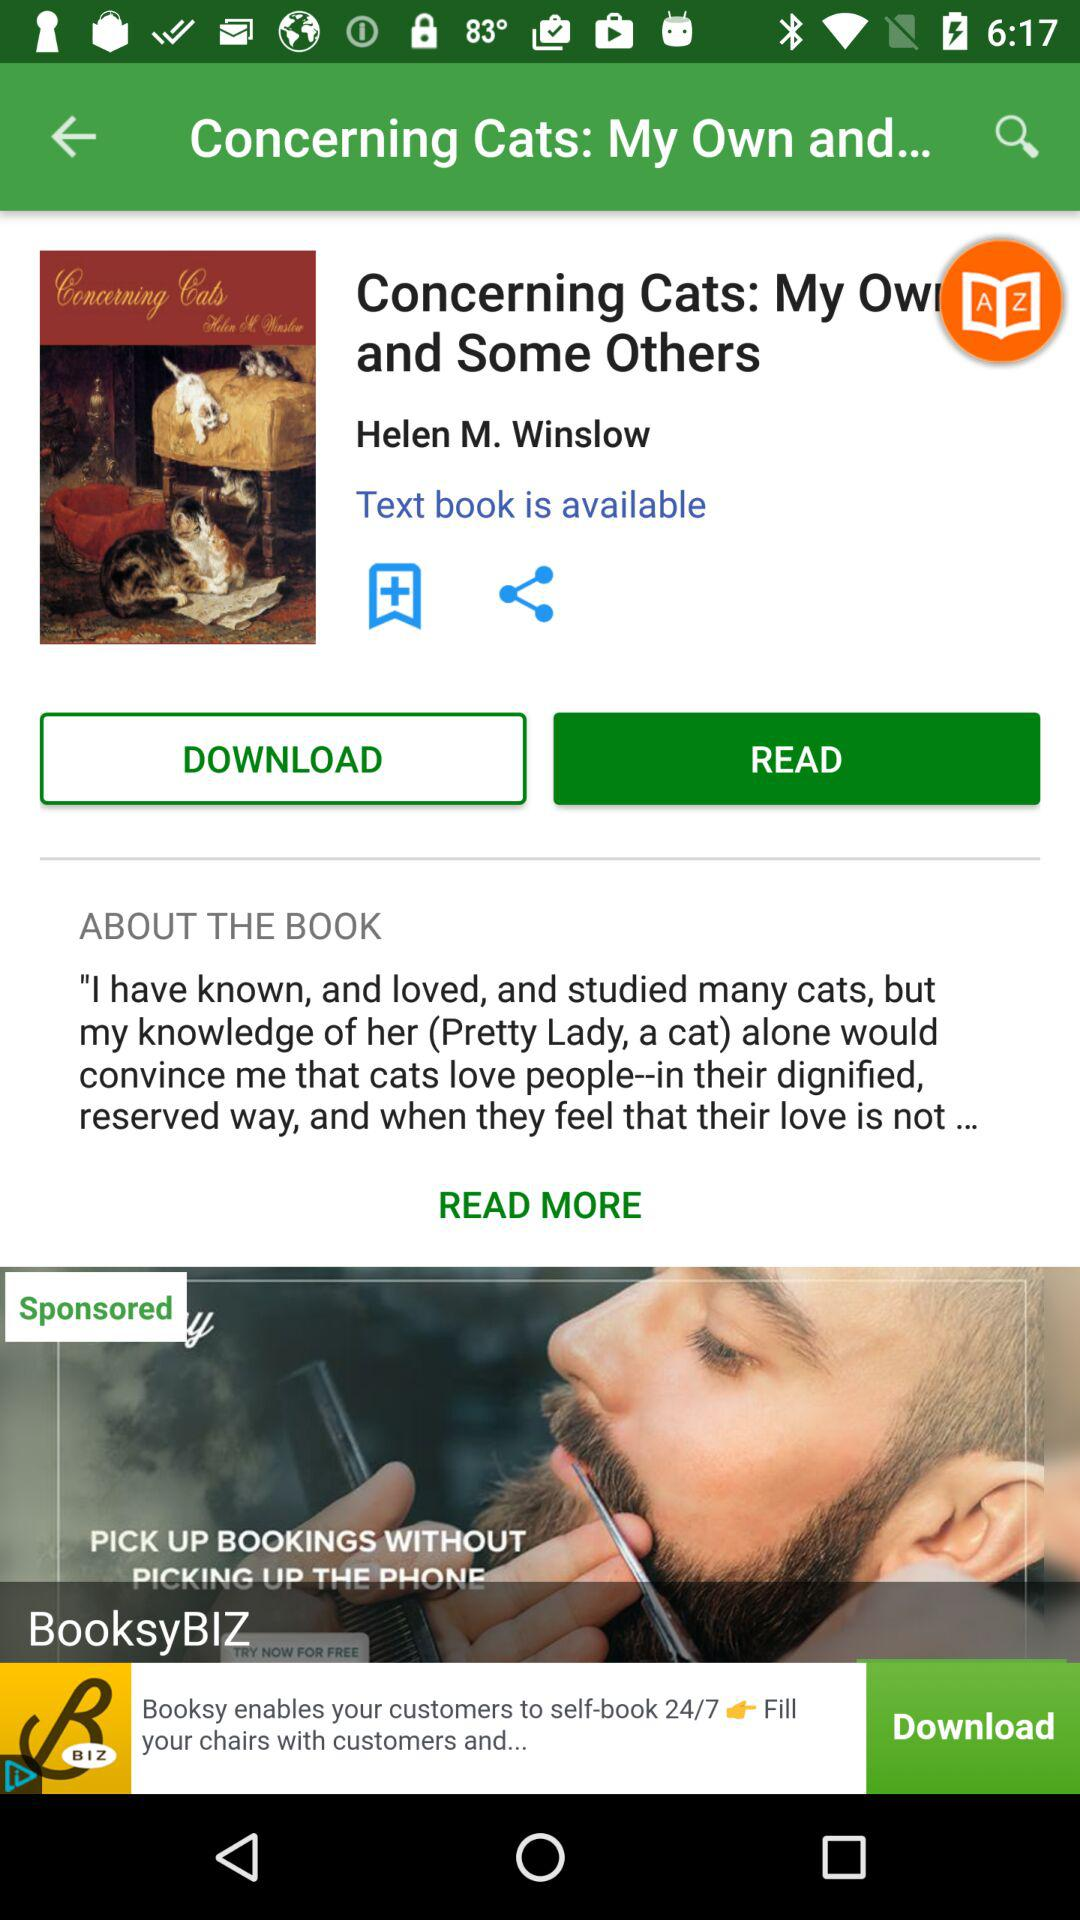What is the application name?
When the provided information is insufficient, respond with <no answer>. <no answer> 